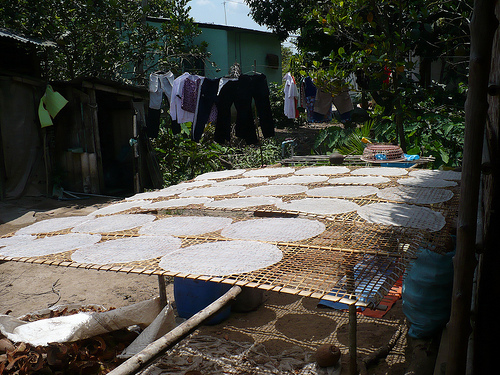<image>
Can you confirm if the mat is above the ground? Yes. The mat is positioned above the ground in the vertical space, higher up in the scene. 